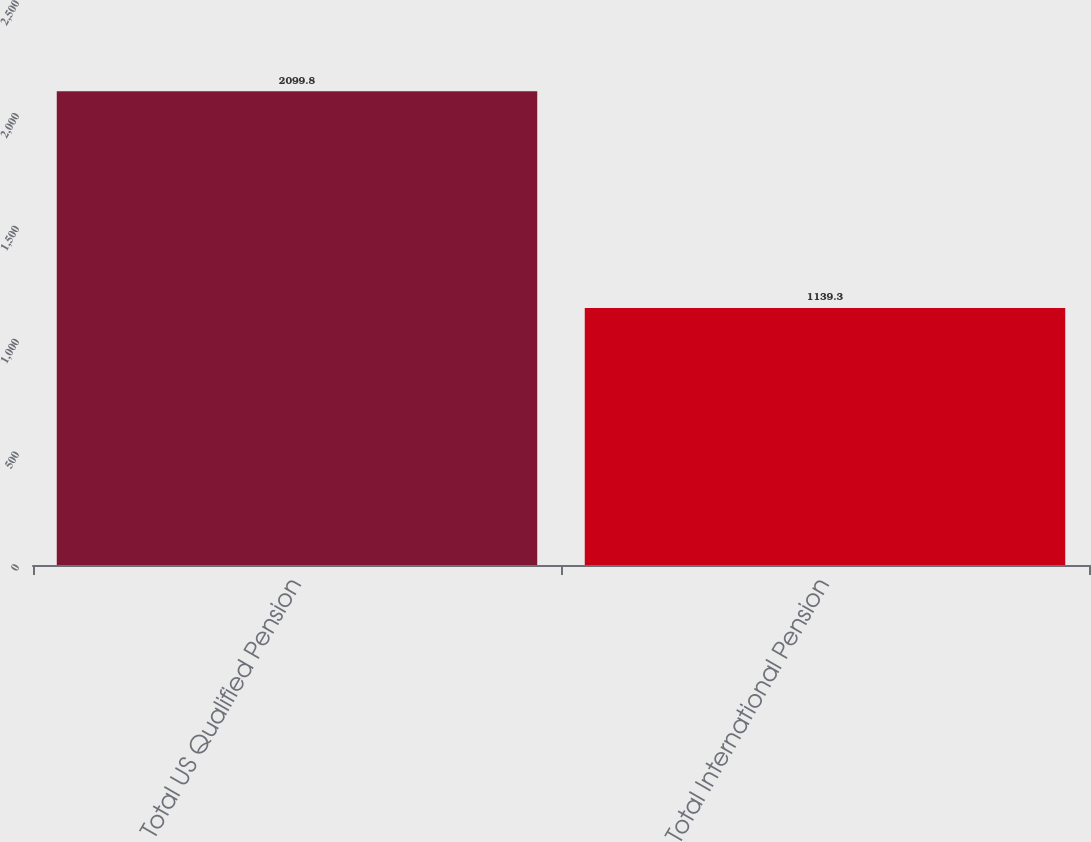<chart> <loc_0><loc_0><loc_500><loc_500><bar_chart><fcel>Total US Qualified Pension<fcel>Total International Pension<nl><fcel>2099.8<fcel>1139.3<nl></chart> 